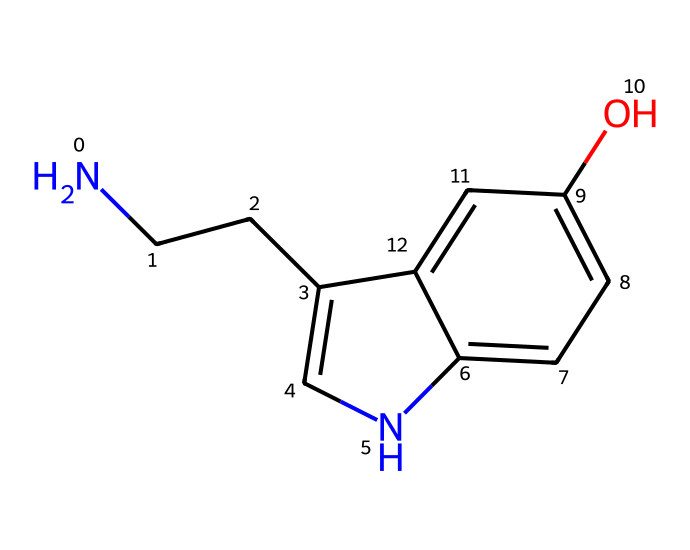What is the molecular formula of serotonin? To determine the molecular formula from the SMILES representation, we identify the number of each type of atom in the structure. In the given SMILES, the atoms include carbon (C), hydrogen (H), nitrogen (N), and oxygen (O). Counting these gives us C10, H12, N2, and O1. Thus, the molecular formula is C10H12N2O.
Answer: C10H12N2O How many rings are present in the structure? By analyzing the SMILES representation, we observe that there are two sections marked by numbers, indicating where the rings close. These indicate that there are two interconnected cycles in the chemical structure of serotonin.
Answer: 2 What type of amine is found in serotonin? In the SMILES representation, we see a nitrogen atom connected to two carbon atoms without any double bonds, indicating a primary amine. This can be deduced from the "N" atom connected to one carbon chain and the rest of the molecule, consistent with a primary amine classification.
Answer: primary amine What functional group is indicated by the "O" in the structure? The "O" in the SMILES corresponds to a hydroxyl (-OH) group, which signifies that serotonin contains a phenolic functional group. The presence of the oxygen bonded to a hydrogen suggests its role in the chemistry of serotonin, specifically as a hydroxy group.
Answer: hydroxyl group How many stereogenic centers are in serotonin? A stereogenic center (or chiral center) is typically a carbon atom bonded to four different groups. In the SMILES structure of serotonin, we look for such carbon atoms. Upon examination, we find only one carbon atom that meets this criterion, indicating there is one stereogenic center in the molecule.
Answer: 1 